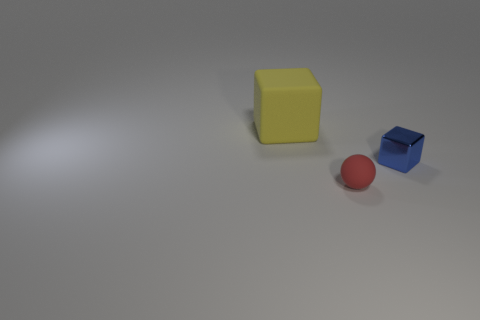The other object that is the same shape as the large yellow matte object is what size?
Offer a very short reply. Small. There is a large object that is made of the same material as the red sphere; what shape is it?
Offer a very short reply. Cube. What is the size of the rubber thing that is behind the cube that is right of the yellow matte thing?
Offer a terse response. Large. The tiny shiny thing to the right of the red sphere is what color?
Make the answer very short. Blue. Are there any blue metallic things of the same shape as the big matte thing?
Provide a short and direct response. Yes. Is the number of blue metallic blocks that are to the left of the large yellow rubber thing less than the number of yellow rubber objects that are to the right of the blue object?
Keep it short and to the point. No. The tiny matte thing is what color?
Provide a short and direct response. Red. Is there a shiny cube to the left of the rubber object that is behind the small blue shiny thing?
Give a very brief answer. No. What number of blue metal things have the same size as the ball?
Your answer should be very brief. 1. There is a red object to the left of the block that is right of the red matte thing; what number of red spheres are behind it?
Offer a very short reply. 0. 